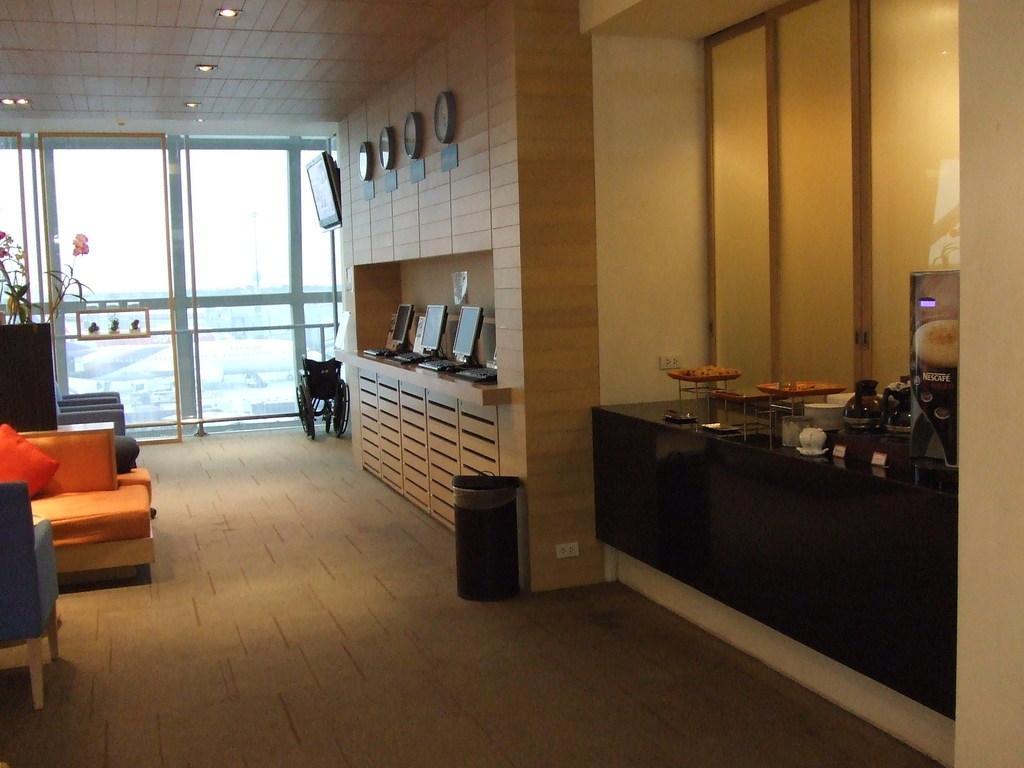Describe this image in one or two sentences. In this image there are laptop,clock,wheelchair,bin on the floor. There are chair and pillows. At the background there is window. On the countertop there is a cup and a jar. 